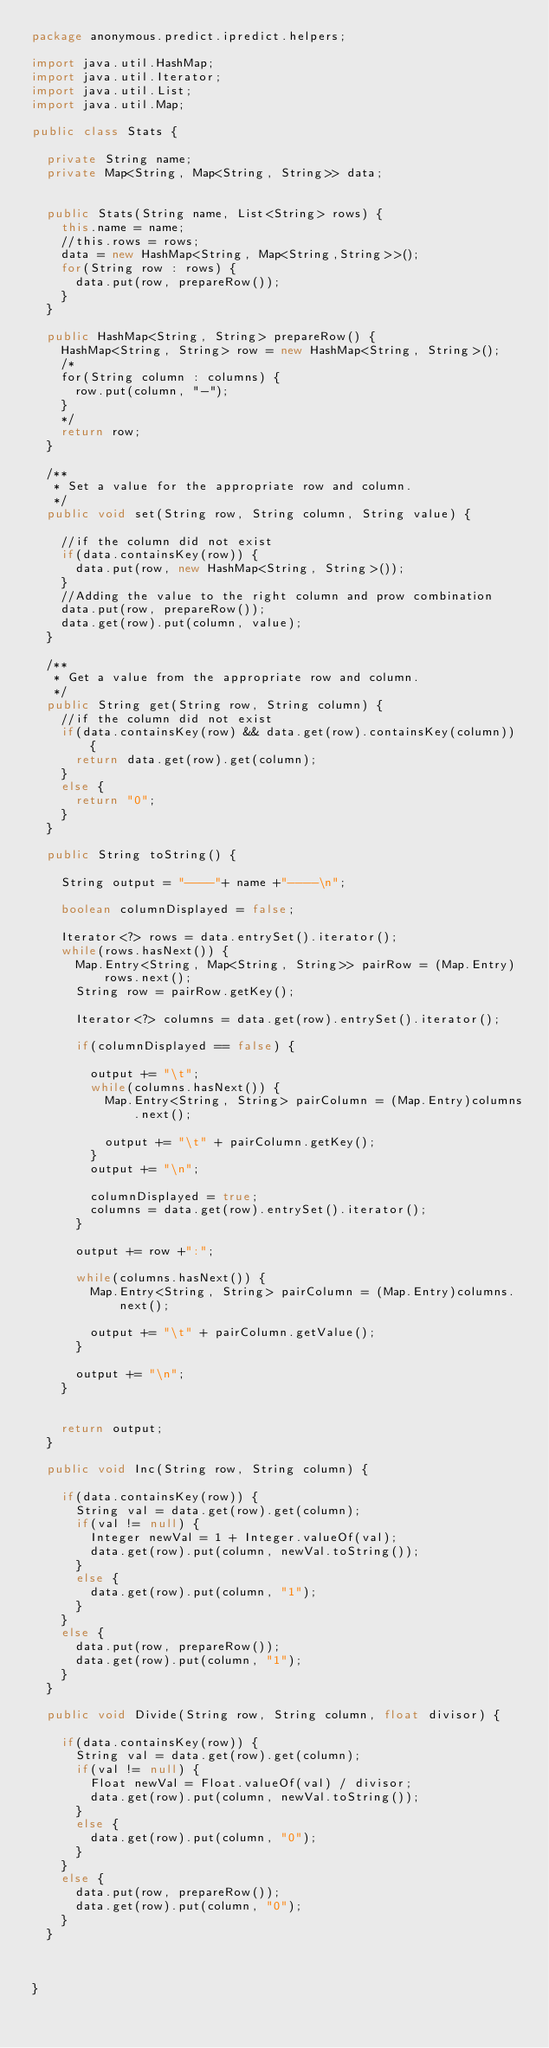<code> <loc_0><loc_0><loc_500><loc_500><_Java_>package anonymous.predict.ipredict.helpers;

import java.util.HashMap;
import java.util.Iterator;
import java.util.List;
import java.util.Map;

public class Stats {

	private String name;
	private Map<String, Map<String, String>> data;
	
	
	public Stats(String name, List<String> rows) {
		this.name = name;
		//this.rows = rows;
		data = new HashMap<String, Map<String,String>>();
		for(String row : rows) {
			data.put(row, prepareRow());
		}
	}
	
	public HashMap<String, String> prepareRow() {
		HashMap<String, String> row = new HashMap<String, String>();
		/*
		for(String column : columns) {
			row.put(column, "-");
		}
		*/
		return row;
	}
	
	/**
	 * Set a value for the appropriate row and column.
	 */
	public void set(String row, String column, String value) {
		
		//if the column did not exist
		if(data.containsKey(row)) {
			data.put(row, new HashMap<String, String>());
		}
		//Adding the value to the right column and prow combination
		data.put(row, prepareRow());
		data.get(row).put(column, value);	
	}
	
	/**
	 * Get a value from the appropriate row and column.
	 */
	public String get(String row, String column) {
		//if the column did not exist
		if(data.containsKey(row) && data.get(row).containsKey(column)) {
			return data.get(row).get(column);
		}
		else {
			return "0";
		}
	}
	
	public String toString() {
		
		String output = "----"+ name +"----\n";
		
		boolean columnDisplayed = false;
		
		Iterator<?> rows = data.entrySet().iterator();
		while(rows.hasNext()) {
			Map.Entry<String, Map<String, String>> pairRow = (Map.Entry)rows.next();
			String row = pairRow.getKey();
			
			Iterator<?> columns = data.get(row).entrySet().iterator();
			
			if(columnDisplayed == false) {
				
				output += "\t";
				while(columns.hasNext()) {
					Map.Entry<String, String> pairColumn = (Map.Entry)columns.next();
					
					output += "\t" + pairColumn.getKey();
				}
				output += "\n";
				
				columnDisplayed = true;
				columns = data.get(row).entrySet().iterator();
			}
			
			output += row +":";
			
			while(columns.hasNext()) {
				Map.Entry<String, String> pairColumn = (Map.Entry)columns.next();
				
				output += "\t" + pairColumn.getValue();
			}
			
			output += "\n";
		}
		
		
		return output;
	}
	
	public void Inc(String row, String column) {
		
		if(data.containsKey(row)) {
			String val = data.get(row).get(column);
			if(val != null) {
				Integer newVal = 1 + Integer.valueOf(val);
				data.get(row).put(column, newVal.toString());
			}
			else {
				data.get(row).put(column, "1");
			}
		}
		else {
			data.put(row, prepareRow());
			data.get(row).put(column, "1");
		}
	}
	
	public void Divide(String row, String column, float divisor) {
		
		if(data.containsKey(row)) {
			String val = data.get(row).get(column);
			if(val != null) {
				Float newVal = Float.valueOf(val) / divisor;
				data.get(row).put(column, newVal.toString());
			}
			else {
				data.get(row).put(column, "0");
			}
		}
		else {
			data.put(row, prepareRow());
			data.get(row).put(column, "0");
		}
	}
	
	

}
</code> 